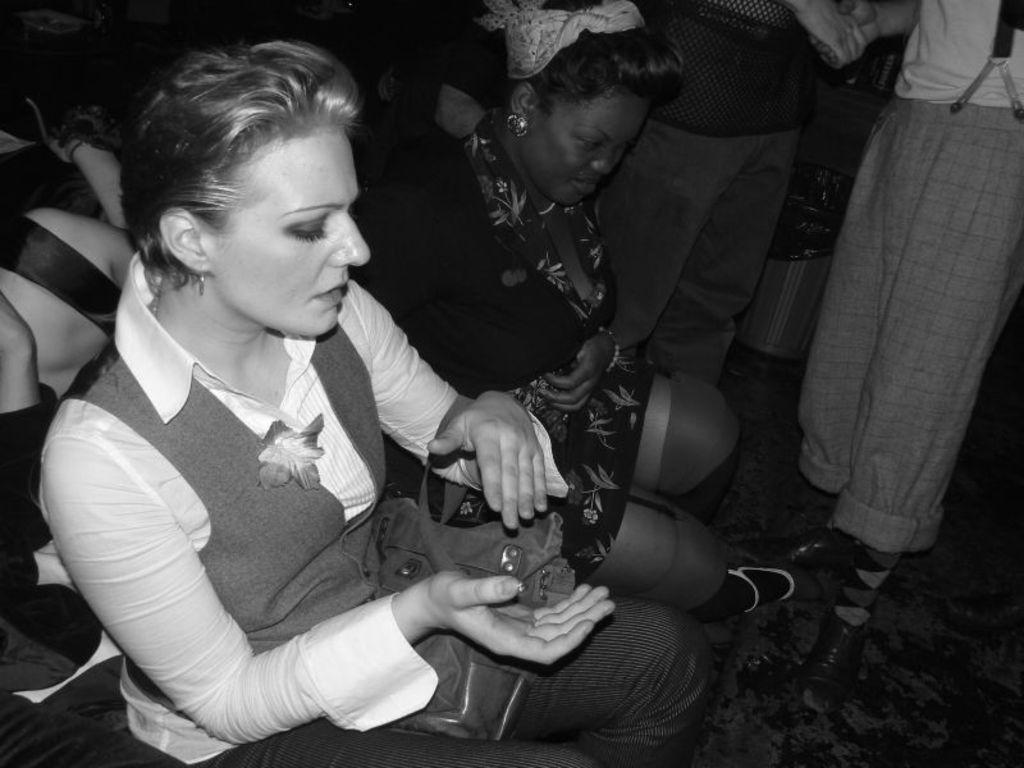How many women are sitting in the image? There are two women sitting in the image. Can you describe the people standing on the right side of the image? Unfortunately, the provided facts do not mention any people standing on the right side of the image. What type of salt can be seen on the table in the image? There is no salt present in the image. How many dolls are visible in the image? There are no dolls present in the image. 